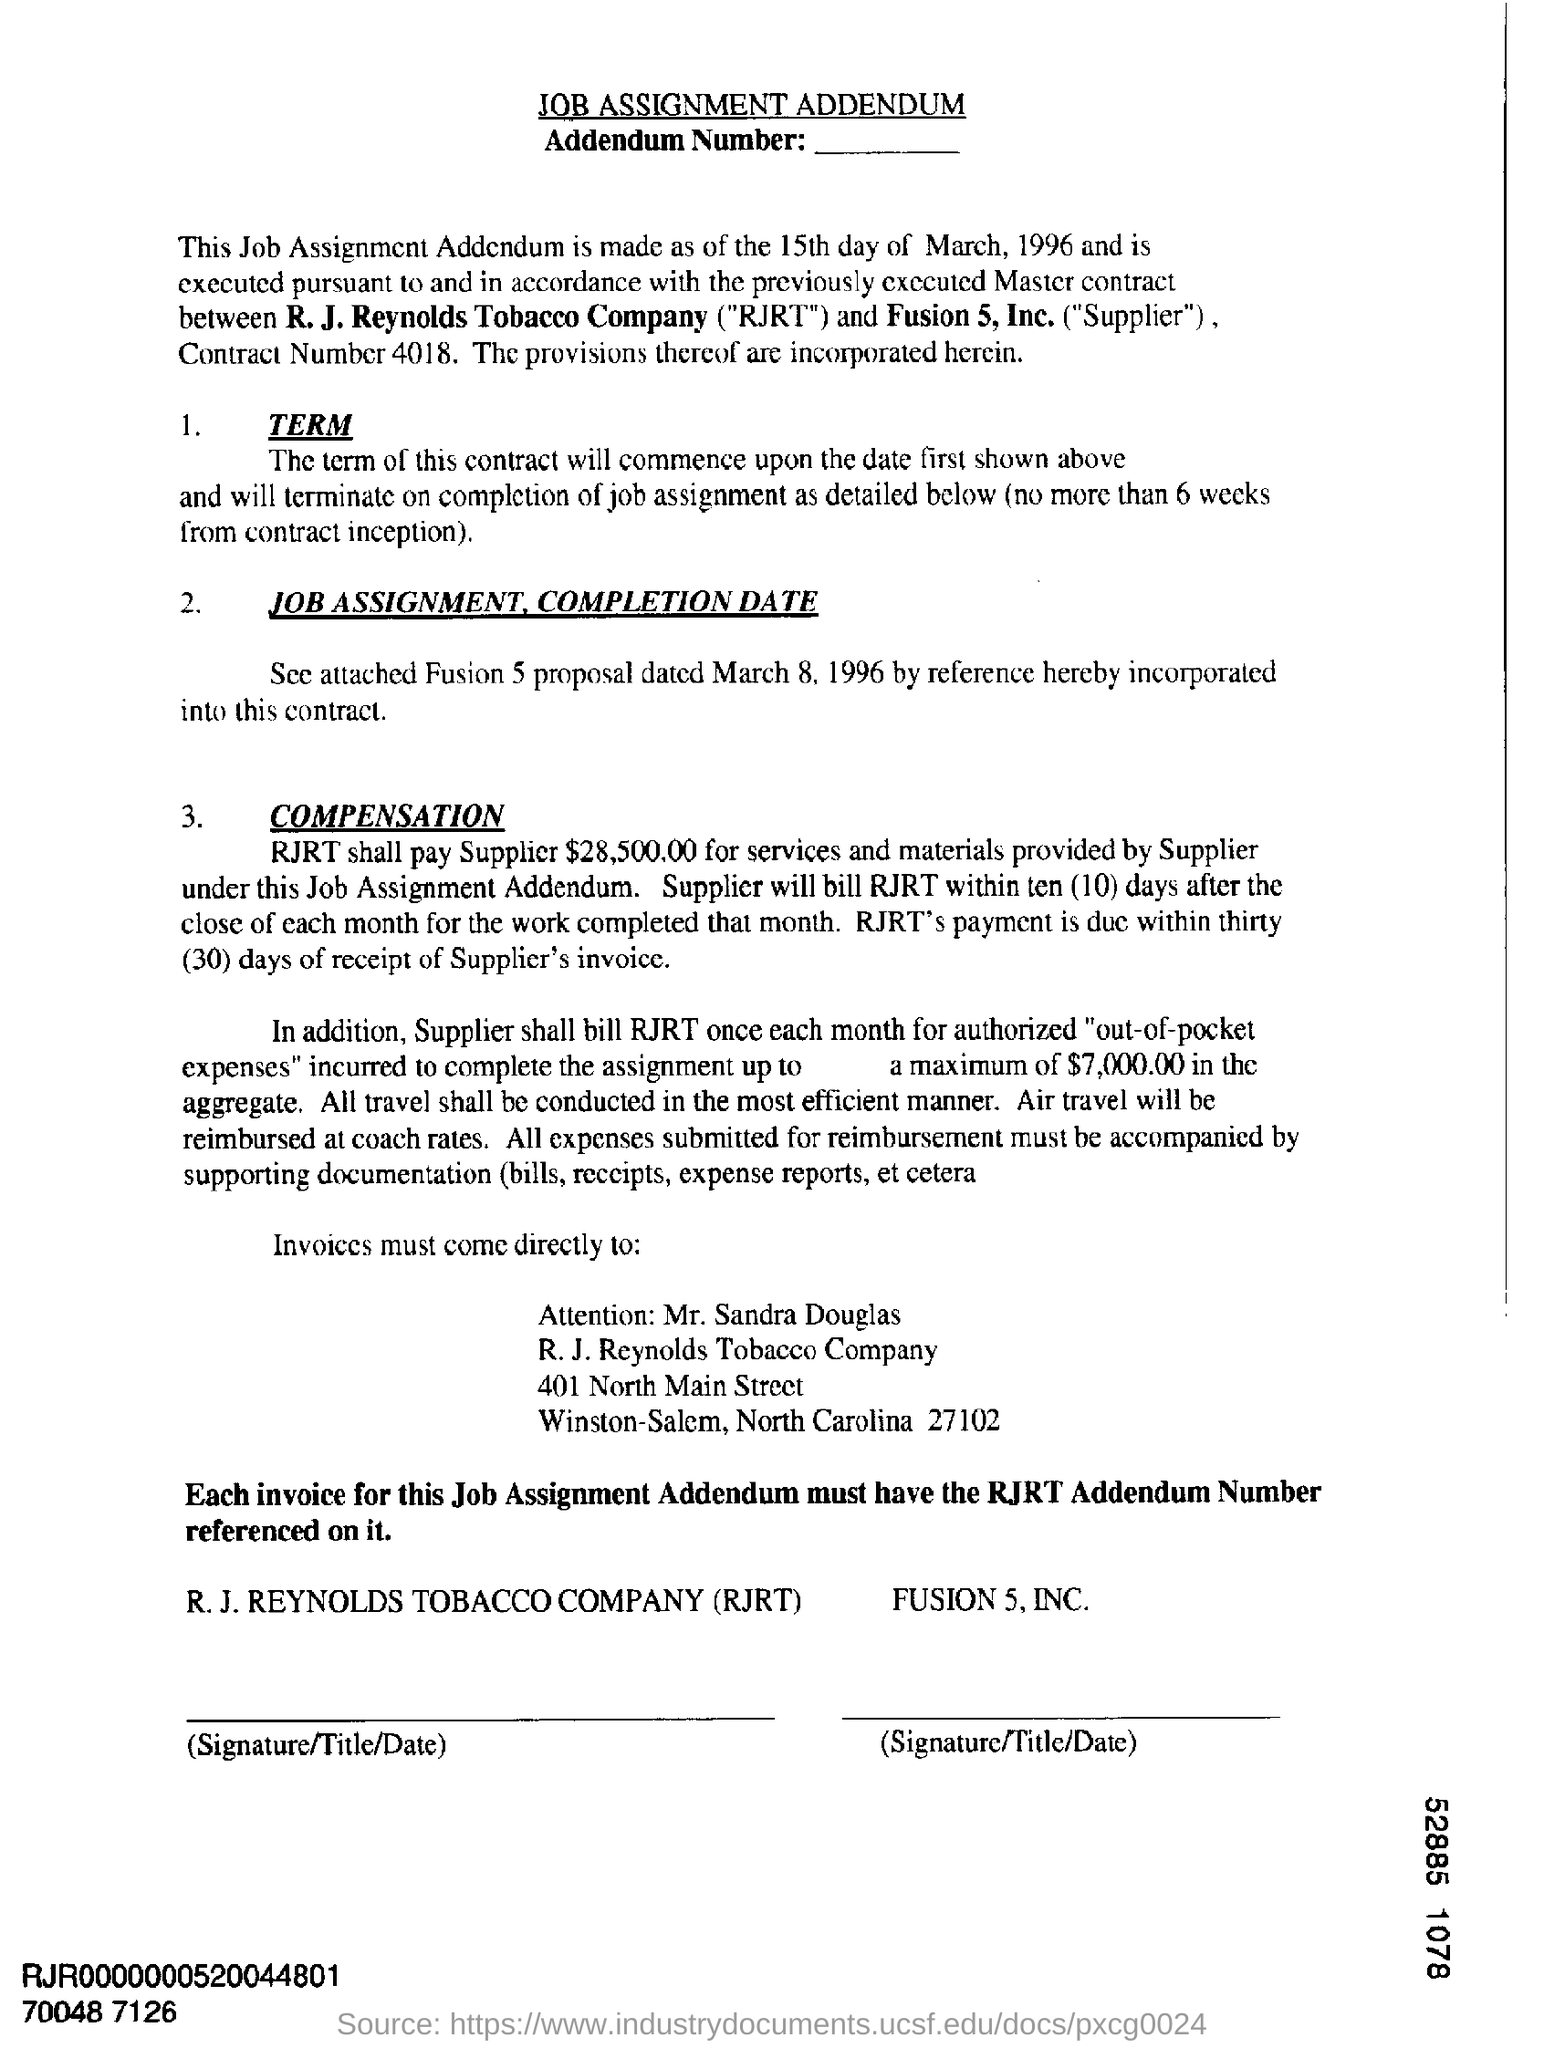Outline some significant characteristics in this image. The Contract Number mentioned in the document is 4018. 